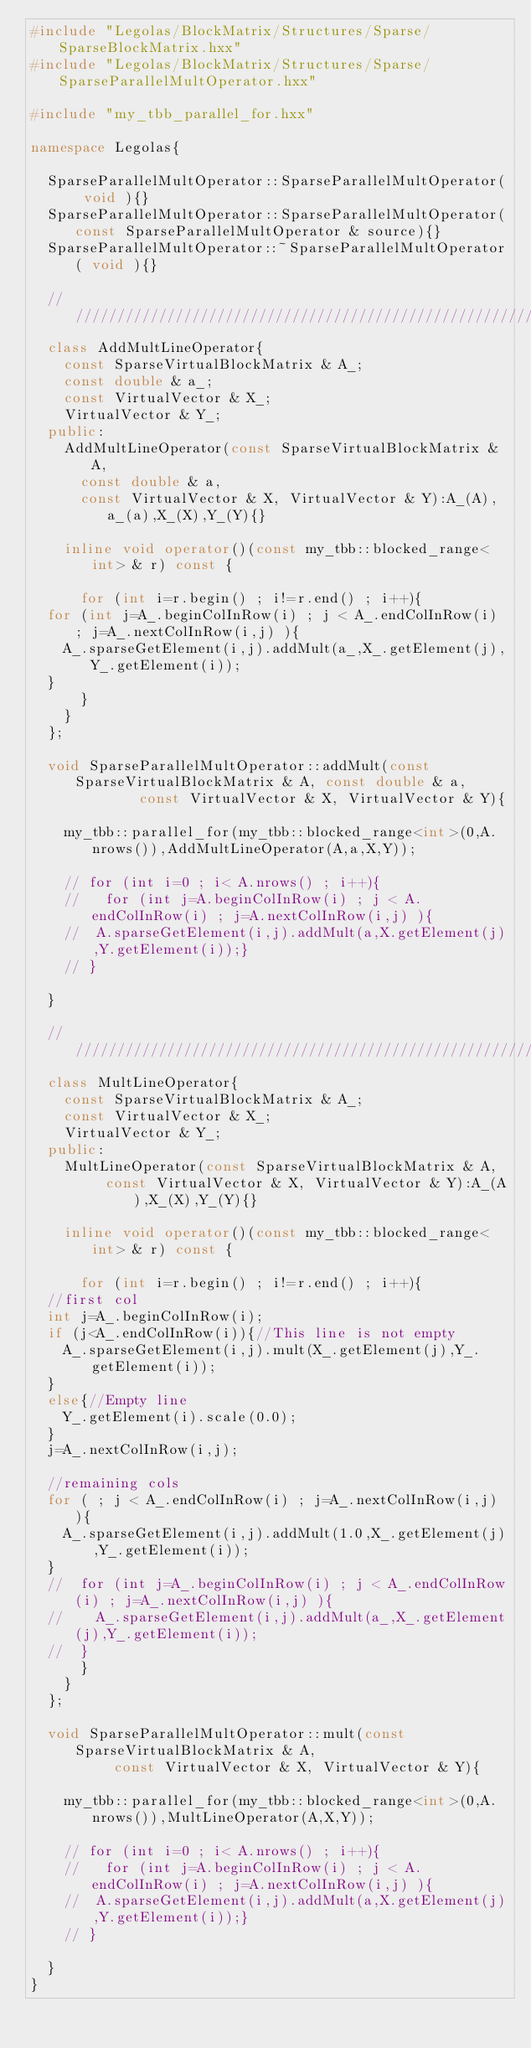<code> <loc_0><loc_0><loc_500><loc_500><_C++_>#include "Legolas/BlockMatrix/Structures/Sparse/SparseBlockMatrix.hxx"
#include "Legolas/BlockMatrix/Structures/Sparse/SparseParallelMultOperator.hxx"

#include "my_tbb_parallel_for.hxx"

namespace Legolas{

  SparseParallelMultOperator::SparseParallelMultOperator( void ){}
  SparseParallelMultOperator::SparseParallelMultOperator(const SparseParallelMultOperator & source){}
  SparseParallelMultOperator::~SparseParallelMultOperator( void ){}
  
  ////////////////////////////////////////////////////////////////////////////////
  class AddMultLineOperator{
    const SparseVirtualBlockMatrix & A_;
    const double & a_;
    const VirtualVector & X_; 
    VirtualVector & Y_;
  public:
    AddMultLineOperator(const SparseVirtualBlockMatrix & A,
			const double & a,
			const VirtualVector & X, VirtualVector & Y):A_(A),a_(a),X_(X),Y_(Y){}
    
    inline void operator()(const my_tbb::blocked_range<int> & r) const {
      
      for (int i=r.begin() ; i!=r.end() ; i++){
	for (int j=A_.beginColInRow(i) ; j < A_.endColInRow(i) ; j=A_.nextColInRow(i,j) ){
	  A_.sparseGetElement(i,j).addMult(a_,X_.getElement(j),Y_.getElement(i));
	}
      }
    }
  };
  
  void SparseParallelMultOperator::addMult(const SparseVirtualBlockMatrix & A, const double & a,
					   const VirtualVector & X, VirtualVector & Y){
    
    my_tbb::parallel_for(my_tbb::blocked_range<int>(0,A.nrows()),AddMultLineOperator(A,a,X,Y));
    
    // for (int i=0 ; i< A.nrows() ; i++){
    //   for (int j=A.beginColInRow(i) ; j < A.endColInRow(i) ; j=A.nextColInRow(i,j) ){
    // 	A.sparseGetElement(i,j).addMult(a,X.getElement(j),Y.getElement(i));}
    // }
    
  }

  ////////////////////////////////////////////////////////////////////////////////
  class MultLineOperator{
    const SparseVirtualBlockMatrix & A_;
    const VirtualVector & X_; 
    VirtualVector & Y_;
  public:
    MultLineOperator(const SparseVirtualBlockMatrix & A,
		     const VirtualVector & X, VirtualVector & Y):A_(A),X_(X),Y_(Y){}
    
    inline void operator()(const my_tbb::blocked_range<int> & r) const {
      
      for (int i=r.begin() ; i!=r.end() ; i++){
	//first col
	int j=A_.beginColInRow(i);
	if (j<A_.endColInRow(i)){//This line is not empty
	  A_.sparseGetElement(i,j).mult(X_.getElement(j),Y_.getElement(i));
	}
	else{//Empty line
	  Y_.getElement(i).scale(0.0);
	}
	j=A_.nextColInRow(i,j);
	
	//remaining cols
	for ( ; j < A_.endColInRow(i) ; j=A_.nextColInRow(i,j) ){
	  A_.sparseGetElement(i,j).addMult(1.0,X_.getElement(j),Y_.getElement(i));
	}
	//	for (int j=A_.beginColInRow(i) ; j < A_.endColInRow(i) ; j=A_.nextColInRow(i,j) ){
	//	  A_.sparseGetElement(i,j).addMult(a_,X_.getElement(j),Y_.getElement(i));
	//	}
      }
    }
  };
  
  void SparseParallelMultOperator::mult(const SparseVirtualBlockMatrix & A,
					const VirtualVector & X, VirtualVector & Y){
    
    my_tbb::parallel_for(my_tbb::blocked_range<int>(0,A.nrows()),MultLineOperator(A,X,Y));
    
    // for (int i=0 ; i< A.nrows() ; i++){
    //   for (int j=A.beginColInRow(i) ; j < A.endColInRow(i) ; j=A.nextColInRow(i,j) ){
    // 	A.sparseGetElement(i,j).addMult(a,X.getElement(j),Y.getElement(i));}
    // }
    
  }
}
    
</code> 